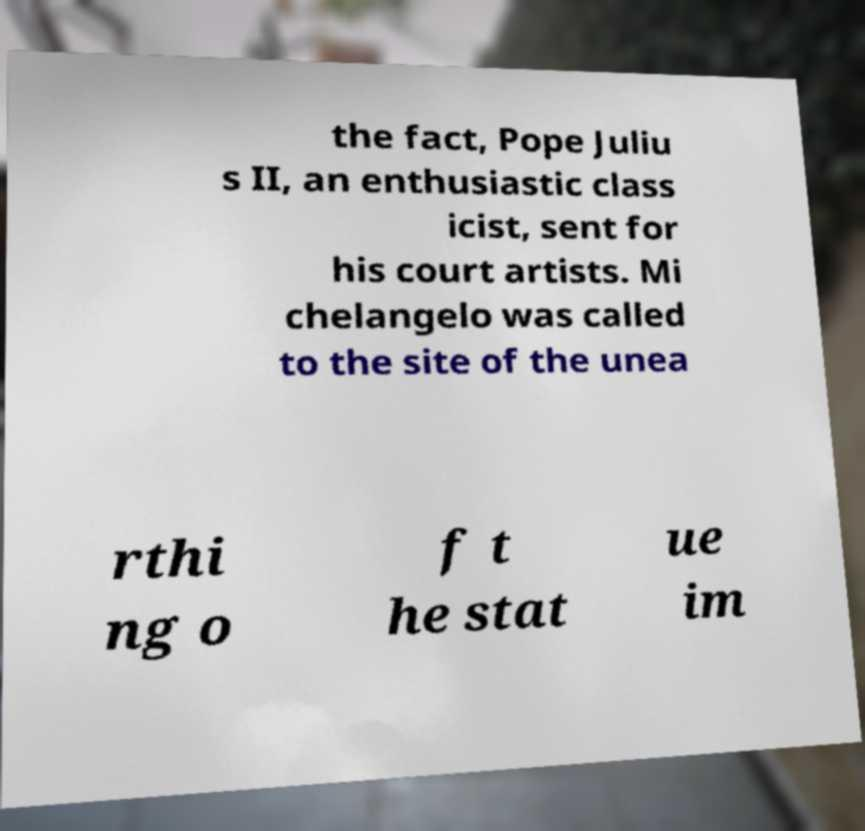What messages or text are displayed in this image? I need them in a readable, typed format. the fact, Pope Juliu s II, an enthusiastic class icist, sent for his court artists. Mi chelangelo was called to the site of the unea rthi ng o f t he stat ue im 